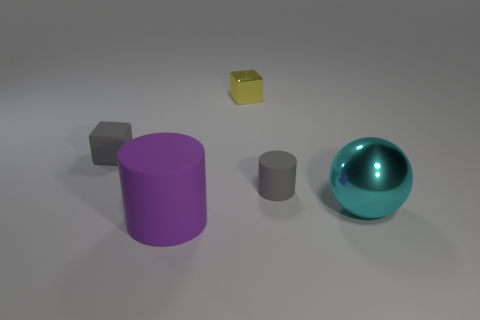How many gray things are behind the big purple matte object?
Offer a very short reply. 2. What number of objects are matte objects that are behind the cyan metal object or cyan objects?
Provide a succinct answer. 3. Are there more gray objects on the left side of the small yellow shiny block than small metallic objects in front of the large rubber thing?
Your answer should be compact. Yes. There is a gray cylinder; does it have the same size as the cylinder on the left side of the yellow shiny block?
Offer a very short reply. No. How many spheres are either yellow shiny objects or purple matte things?
Make the answer very short. 0. What size is the gray object that is made of the same material as the tiny gray cube?
Give a very brief answer. Small. There is a rubber cylinder that is to the right of the large purple thing; is its size the same as the metal thing in front of the tiny shiny block?
Keep it short and to the point. No. What number of things are matte things or large purple rubber balls?
Give a very brief answer. 3. The tiny metal object is what shape?
Offer a very short reply. Cube. There is a gray matte thing that is the same shape as the small metal thing; what size is it?
Provide a short and direct response. Small. 